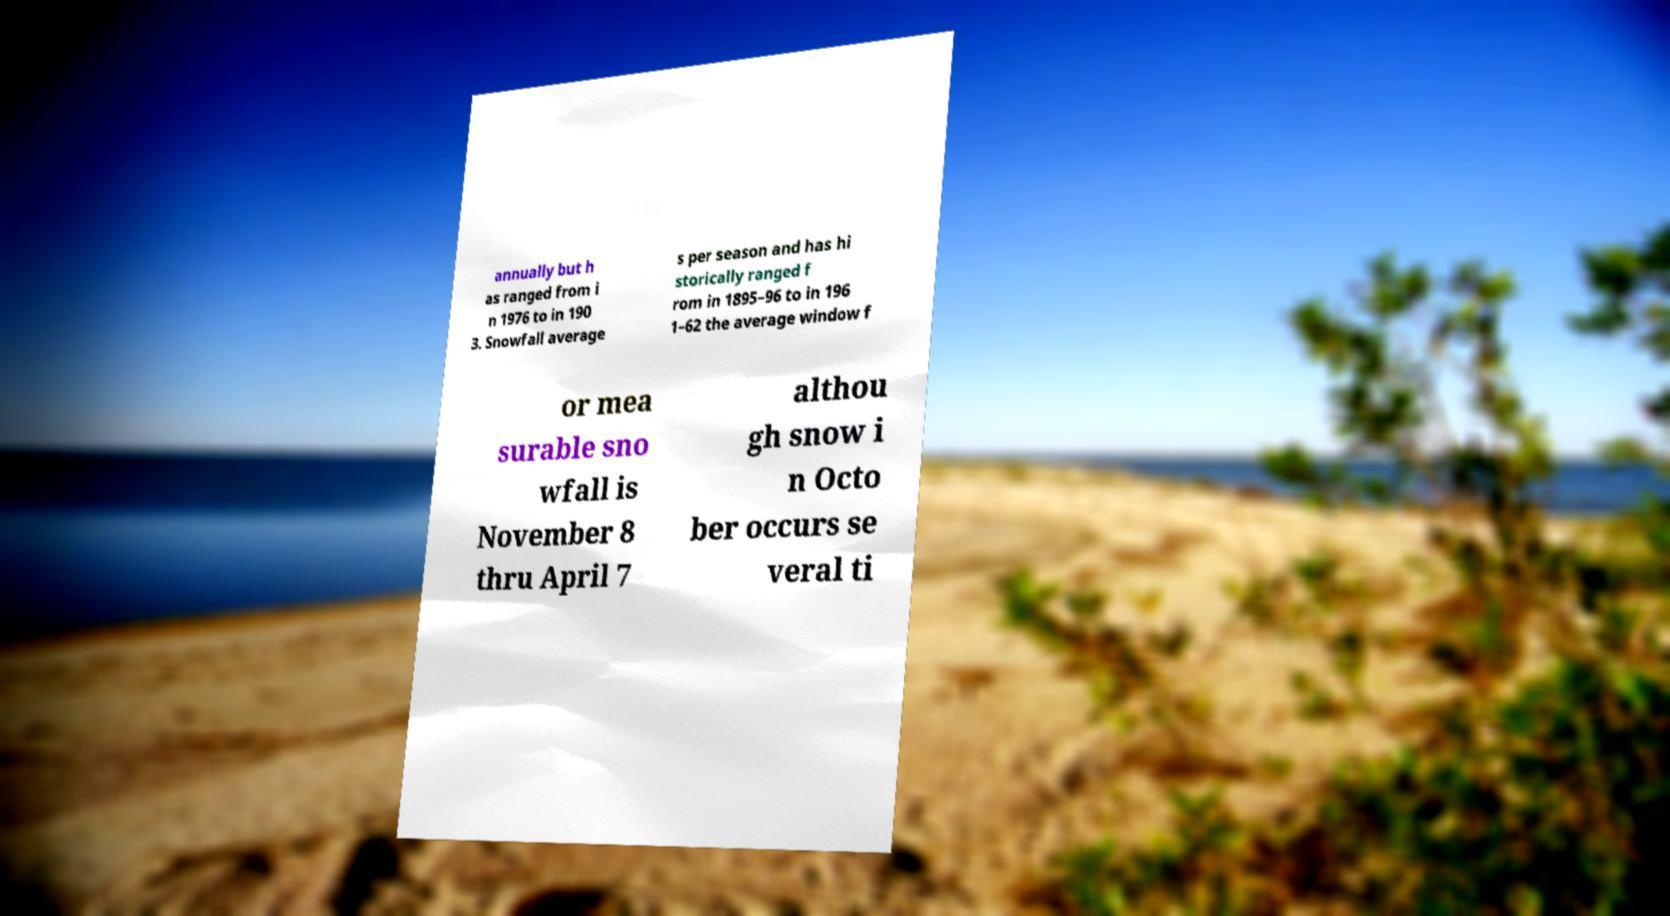Can you read and provide the text displayed in the image?This photo seems to have some interesting text. Can you extract and type it out for me? annually but h as ranged from i n 1976 to in 190 3. Snowfall average s per season and has hi storically ranged f rom in 1895–96 to in 196 1–62 the average window f or mea surable sno wfall is November 8 thru April 7 althou gh snow i n Octo ber occurs se veral ti 